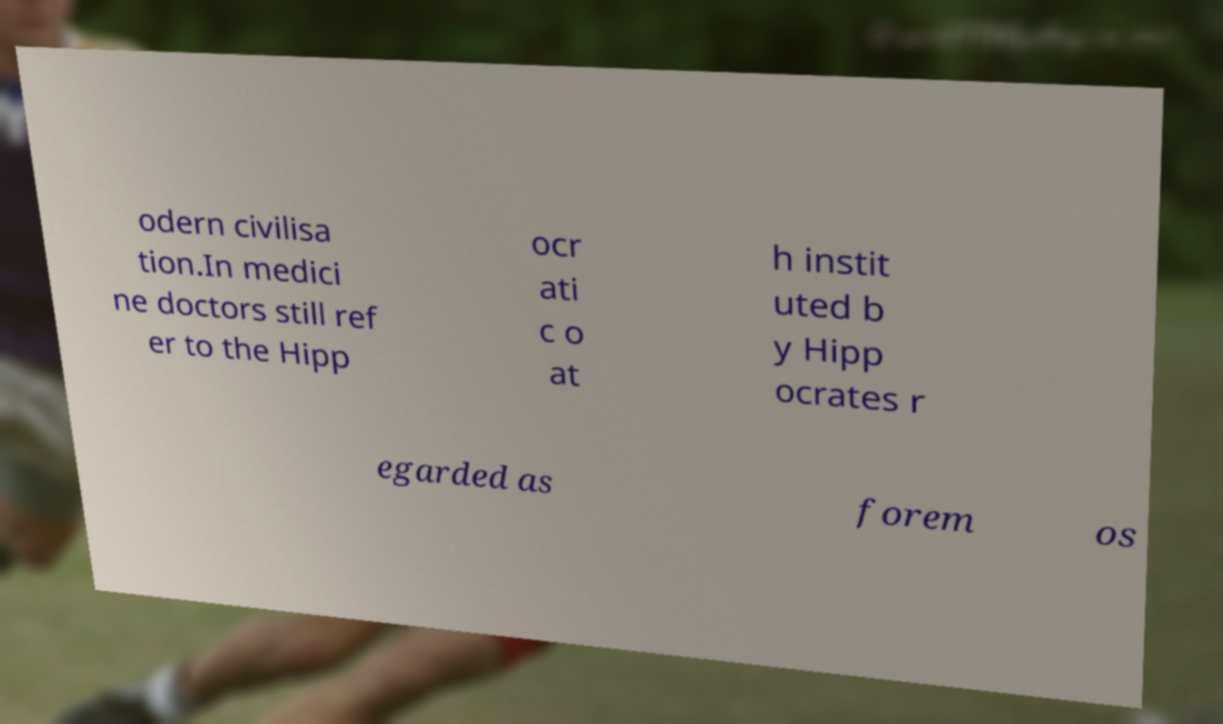What messages or text are displayed in this image? I need them in a readable, typed format. odern civilisa tion.In medici ne doctors still ref er to the Hipp ocr ati c o at h instit uted b y Hipp ocrates r egarded as forem os 